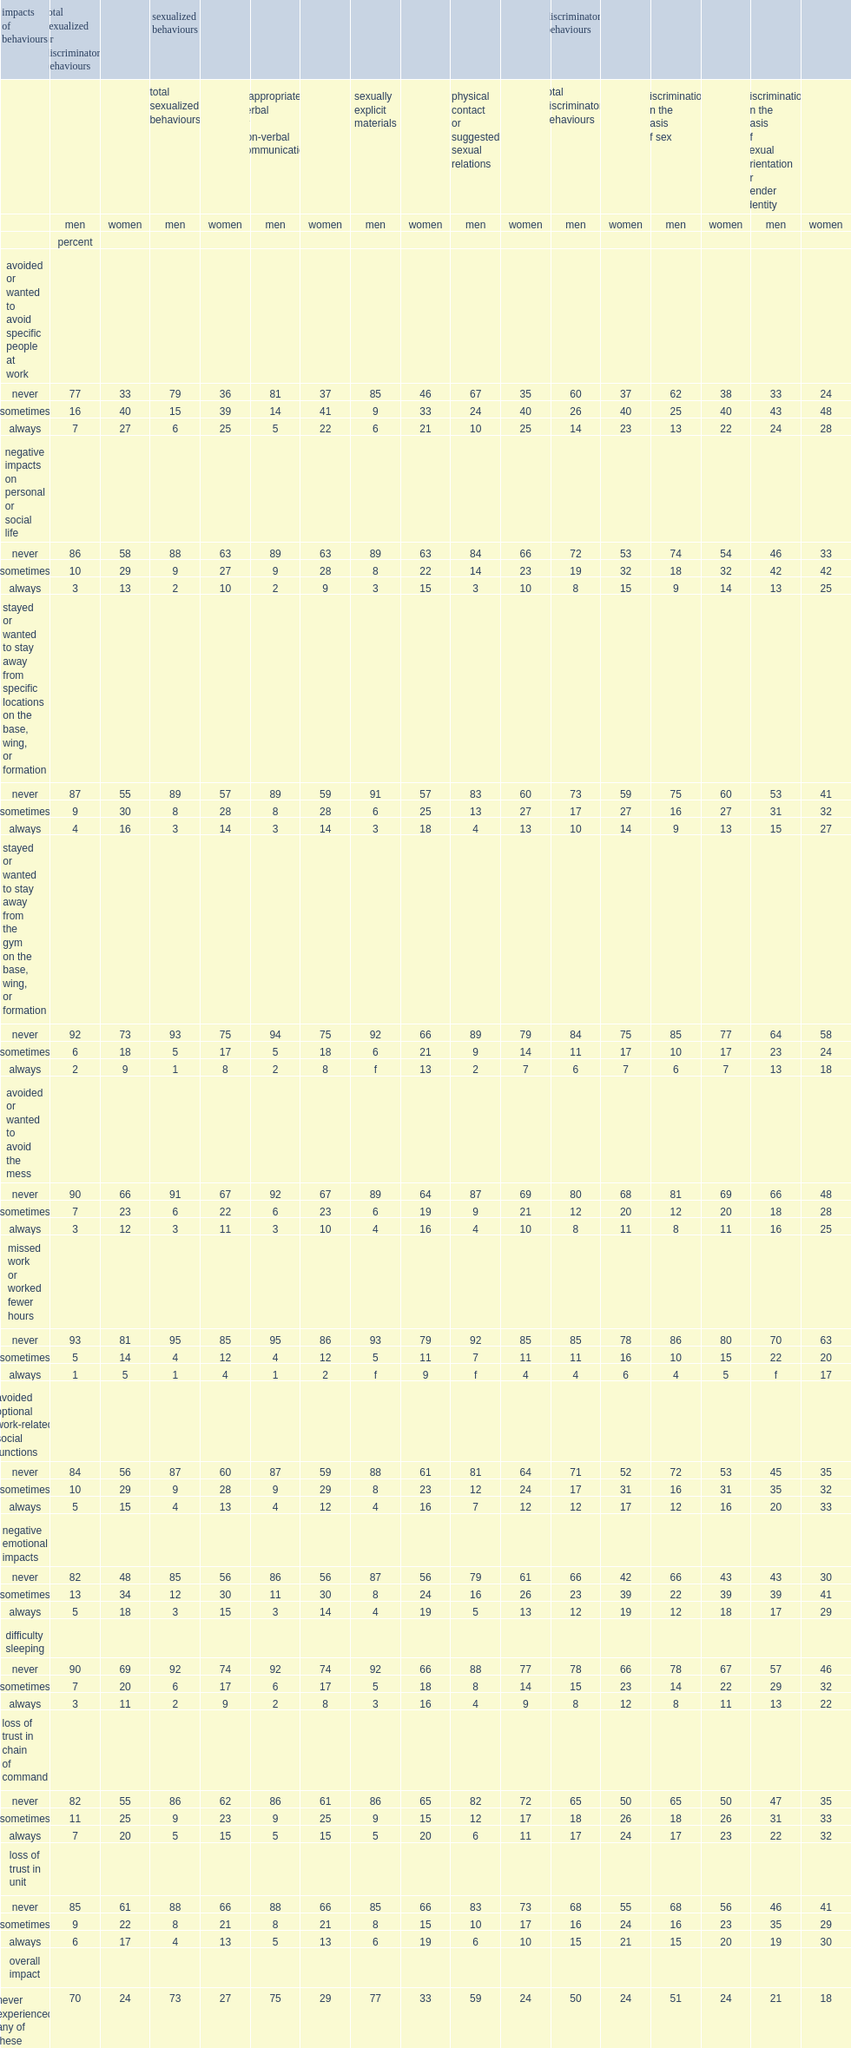Which gender were more likely to report negative impacts as a result among regular force members who experienced sexualized or discriminatory behaviours? Women. What is the proportion of men who experienced sexualized or discriminatory behaviour and said they did not experience any negative impacts? 70.0. What is the proportion of women who experienced sexualized or discriminatory behaviour and said they did not experience any negative impacts? 24.0. What is the proportion of men who experienced negative impacts as a result after experiencing discriminatory behaviour due to their sex, gender, or sexual orientation? 51. What is the proportion of women who experienced negative impacts as a result after experiencing discriminatory behaviour due to their sex, gender, or sexual orientation? 76. Among different sexualized or discriminatory behaviours, what was the behaviour most likely to result in negative impacts? Discrimination on the basis of sexual orientation or gender identity. What is the proportion of men who sometimes or always experienced negative personal impacts as a result? 79. What is the proportion of women who sometimes or always experienced negative personal impacts as a result? 82. 